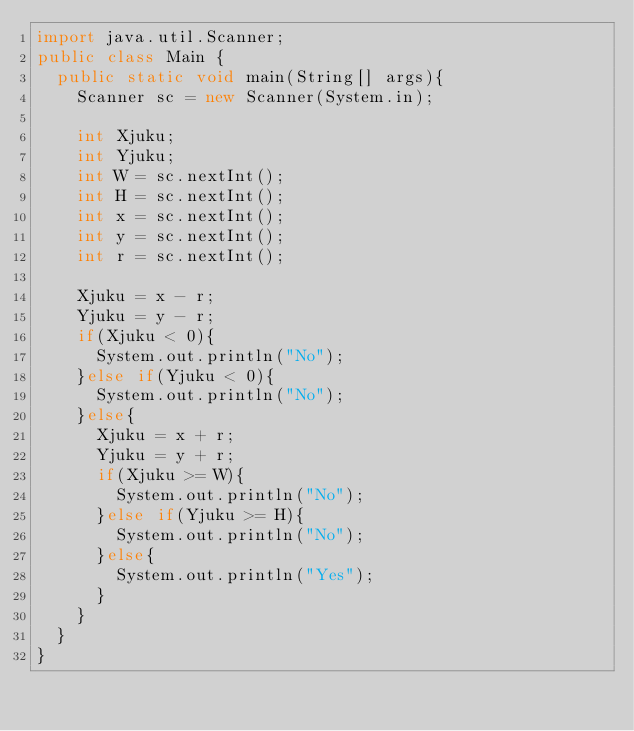Convert code to text. <code><loc_0><loc_0><loc_500><loc_500><_Java_>import java.util.Scanner;
public class Main {
	public static void main(String[] args){
		Scanner sc = new Scanner(System.in);

		int Xjuku;
		int Yjuku;
		int W = sc.nextInt();
		int H = sc.nextInt();
		int x = sc.nextInt();
		int y = sc.nextInt();
		int r = sc.nextInt();
		
		Xjuku = x - r;
		Yjuku = y - r;
		if(Xjuku < 0){
			System.out.println("No");
		}else if(Yjuku < 0){
			System.out.println("No");
		}else{
			Xjuku = x + r;
			Yjuku = y + r;
			if(Xjuku >= W){
				System.out.println("No");
			}else if(Yjuku >= H){
				System.out.println("No");
			}else{
				System.out.println("Yes");
			}
		}
	}
}
</code> 